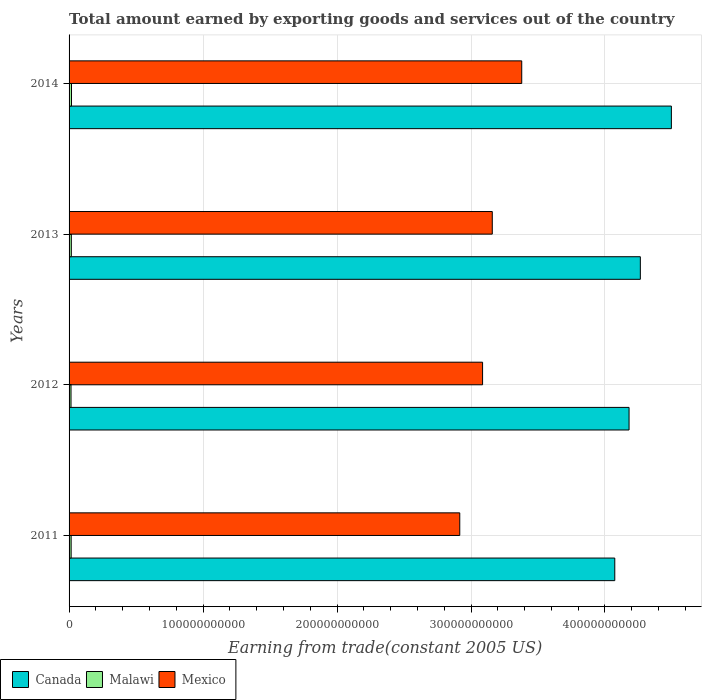Are the number of bars per tick equal to the number of legend labels?
Your response must be concise. Yes. What is the total amount earned by exporting goods and services in Canada in 2014?
Your response must be concise. 4.50e+11. Across all years, what is the maximum total amount earned by exporting goods and services in Malawi?
Your response must be concise. 1.81e+09. Across all years, what is the minimum total amount earned by exporting goods and services in Malawi?
Your answer should be very brief. 1.46e+09. In which year was the total amount earned by exporting goods and services in Canada minimum?
Offer a terse response. 2011. What is the total total amount earned by exporting goods and services in Mexico in the graph?
Offer a terse response. 1.25e+12. What is the difference between the total amount earned by exporting goods and services in Mexico in 2012 and that in 2013?
Keep it short and to the point. -7.25e+09. What is the difference between the total amount earned by exporting goods and services in Mexico in 2011 and the total amount earned by exporting goods and services in Malawi in 2012?
Keep it short and to the point. 2.90e+11. What is the average total amount earned by exporting goods and services in Mexico per year?
Give a very brief answer. 3.13e+11. In the year 2011, what is the difference between the total amount earned by exporting goods and services in Canada and total amount earned by exporting goods and services in Mexico?
Your answer should be very brief. 1.16e+11. In how many years, is the total amount earned by exporting goods and services in Malawi greater than 40000000000 US$?
Your response must be concise. 0. What is the ratio of the total amount earned by exporting goods and services in Canada in 2012 to that in 2014?
Offer a very short reply. 0.93. Is the total amount earned by exporting goods and services in Canada in 2011 less than that in 2012?
Provide a short and direct response. Yes. What is the difference between the highest and the second highest total amount earned by exporting goods and services in Malawi?
Offer a terse response. 1.25e+08. What is the difference between the highest and the lowest total amount earned by exporting goods and services in Malawi?
Ensure brevity in your answer.  3.57e+08. Is the sum of the total amount earned by exporting goods and services in Malawi in 2012 and 2013 greater than the maximum total amount earned by exporting goods and services in Canada across all years?
Offer a very short reply. No. What does the 2nd bar from the top in 2011 represents?
Give a very brief answer. Malawi. How many bars are there?
Offer a very short reply. 12. What is the difference between two consecutive major ticks on the X-axis?
Offer a terse response. 1.00e+11. Are the values on the major ticks of X-axis written in scientific E-notation?
Your answer should be very brief. No. Does the graph contain any zero values?
Your response must be concise. No. How many legend labels are there?
Give a very brief answer. 3. What is the title of the graph?
Give a very brief answer. Total amount earned by exporting goods and services out of the country. Does "Hong Kong" appear as one of the legend labels in the graph?
Keep it short and to the point. No. What is the label or title of the X-axis?
Offer a very short reply. Earning from trade(constant 2005 US). What is the Earning from trade(constant 2005 US) in Canada in 2011?
Provide a succinct answer. 4.07e+11. What is the Earning from trade(constant 2005 US) in Malawi in 2011?
Provide a succinct answer. 1.54e+09. What is the Earning from trade(constant 2005 US) in Mexico in 2011?
Your response must be concise. 2.92e+11. What is the Earning from trade(constant 2005 US) in Canada in 2012?
Provide a succinct answer. 4.18e+11. What is the Earning from trade(constant 2005 US) of Malawi in 2012?
Offer a terse response. 1.46e+09. What is the Earning from trade(constant 2005 US) in Mexico in 2012?
Provide a succinct answer. 3.09e+11. What is the Earning from trade(constant 2005 US) of Canada in 2013?
Your response must be concise. 4.26e+11. What is the Earning from trade(constant 2005 US) of Malawi in 2013?
Keep it short and to the point. 1.69e+09. What is the Earning from trade(constant 2005 US) in Mexico in 2013?
Provide a short and direct response. 3.16e+11. What is the Earning from trade(constant 2005 US) in Canada in 2014?
Your answer should be compact. 4.50e+11. What is the Earning from trade(constant 2005 US) of Malawi in 2014?
Ensure brevity in your answer.  1.81e+09. What is the Earning from trade(constant 2005 US) in Mexico in 2014?
Ensure brevity in your answer.  3.38e+11. Across all years, what is the maximum Earning from trade(constant 2005 US) in Canada?
Your answer should be very brief. 4.50e+11. Across all years, what is the maximum Earning from trade(constant 2005 US) in Malawi?
Your answer should be very brief. 1.81e+09. Across all years, what is the maximum Earning from trade(constant 2005 US) of Mexico?
Provide a succinct answer. 3.38e+11. Across all years, what is the minimum Earning from trade(constant 2005 US) of Canada?
Give a very brief answer. 4.07e+11. Across all years, what is the minimum Earning from trade(constant 2005 US) in Malawi?
Keep it short and to the point. 1.46e+09. Across all years, what is the minimum Earning from trade(constant 2005 US) of Mexico?
Provide a short and direct response. 2.92e+11. What is the total Earning from trade(constant 2005 US) of Canada in the graph?
Provide a short and direct response. 1.70e+12. What is the total Earning from trade(constant 2005 US) in Malawi in the graph?
Your answer should be compact. 6.50e+09. What is the total Earning from trade(constant 2005 US) of Mexico in the graph?
Ensure brevity in your answer.  1.25e+12. What is the difference between the Earning from trade(constant 2005 US) in Canada in 2011 and that in 2012?
Keep it short and to the point. -1.07e+1. What is the difference between the Earning from trade(constant 2005 US) in Malawi in 2011 and that in 2012?
Give a very brief answer. 8.46e+07. What is the difference between the Earning from trade(constant 2005 US) of Mexico in 2011 and that in 2012?
Your response must be concise. -1.70e+1. What is the difference between the Earning from trade(constant 2005 US) of Canada in 2011 and that in 2013?
Your answer should be compact. -1.91e+1. What is the difference between the Earning from trade(constant 2005 US) in Malawi in 2011 and that in 2013?
Your answer should be compact. -1.48e+08. What is the difference between the Earning from trade(constant 2005 US) in Mexico in 2011 and that in 2013?
Offer a terse response. -2.43e+1. What is the difference between the Earning from trade(constant 2005 US) of Canada in 2011 and that in 2014?
Your answer should be compact. -4.22e+1. What is the difference between the Earning from trade(constant 2005 US) in Malawi in 2011 and that in 2014?
Provide a short and direct response. -2.72e+08. What is the difference between the Earning from trade(constant 2005 US) of Mexico in 2011 and that in 2014?
Offer a very short reply. -4.63e+1. What is the difference between the Earning from trade(constant 2005 US) of Canada in 2012 and that in 2013?
Provide a short and direct response. -8.42e+09. What is the difference between the Earning from trade(constant 2005 US) of Malawi in 2012 and that in 2013?
Offer a terse response. -2.32e+08. What is the difference between the Earning from trade(constant 2005 US) of Mexico in 2012 and that in 2013?
Make the answer very short. -7.25e+09. What is the difference between the Earning from trade(constant 2005 US) of Canada in 2012 and that in 2014?
Your answer should be very brief. -3.16e+1. What is the difference between the Earning from trade(constant 2005 US) in Malawi in 2012 and that in 2014?
Keep it short and to the point. -3.57e+08. What is the difference between the Earning from trade(constant 2005 US) of Mexico in 2012 and that in 2014?
Offer a terse response. -2.92e+1. What is the difference between the Earning from trade(constant 2005 US) in Canada in 2013 and that in 2014?
Offer a terse response. -2.32e+1. What is the difference between the Earning from trade(constant 2005 US) of Malawi in 2013 and that in 2014?
Your answer should be compact. -1.25e+08. What is the difference between the Earning from trade(constant 2005 US) of Mexico in 2013 and that in 2014?
Your answer should be compact. -2.20e+1. What is the difference between the Earning from trade(constant 2005 US) in Canada in 2011 and the Earning from trade(constant 2005 US) in Malawi in 2012?
Give a very brief answer. 4.06e+11. What is the difference between the Earning from trade(constant 2005 US) in Canada in 2011 and the Earning from trade(constant 2005 US) in Mexico in 2012?
Provide a succinct answer. 9.87e+1. What is the difference between the Earning from trade(constant 2005 US) of Malawi in 2011 and the Earning from trade(constant 2005 US) of Mexico in 2012?
Give a very brief answer. -3.07e+11. What is the difference between the Earning from trade(constant 2005 US) of Canada in 2011 and the Earning from trade(constant 2005 US) of Malawi in 2013?
Ensure brevity in your answer.  4.06e+11. What is the difference between the Earning from trade(constant 2005 US) in Canada in 2011 and the Earning from trade(constant 2005 US) in Mexico in 2013?
Offer a terse response. 9.14e+1. What is the difference between the Earning from trade(constant 2005 US) in Malawi in 2011 and the Earning from trade(constant 2005 US) in Mexico in 2013?
Make the answer very short. -3.14e+11. What is the difference between the Earning from trade(constant 2005 US) in Canada in 2011 and the Earning from trade(constant 2005 US) in Malawi in 2014?
Offer a terse response. 4.05e+11. What is the difference between the Earning from trade(constant 2005 US) of Canada in 2011 and the Earning from trade(constant 2005 US) of Mexico in 2014?
Keep it short and to the point. 6.94e+1. What is the difference between the Earning from trade(constant 2005 US) of Malawi in 2011 and the Earning from trade(constant 2005 US) of Mexico in 2014?
Give a very brief answer. -3.36e+11. What is the difference between the Earning from trade(constant 2005 US) in Canada in 2012 and the Earning from trade(constant 2005 US) in Malawi in 2013?
Keep it short and to the point. 4.16e+11. What is the difference between the Earning from trade(constant 2005 US) of Canada in 2012 and the Earning from trade(constant 2005 US) of Mexico in 2013?
Offer a terse response. 1.02e+11. What is the difference between the Earning from trade(constant 2005 US) in Malawi in 2012 and the Earning from trade(constant 2005 US) in Mexico in 2013?
Give a very brief answer. -3.14e+11. What is the difference between the Earning from trade(constant 2005 US) of Canada in 2012 and the Earning from trade(constant 2005 US) of Malawi in 2014?
Your answer should be very brief. 4.16e+11. What is the difference between the Earning from trade(constant 2005 US) in Canada in 2012 and the Earning from trade(constant 2005 US) in Mexico in 2014?
Ensure brevity in your answer.  8.01e+1. What is the difference between the Earning from trade(constant 2005 US) of Malawi in 2012 and the Earning from trade(constant 2005 US) of Mexico in 2014?
Your answer should be compact. -3.36e+11. What is the difference between the Earning from trade(constant 2005 US) in Canada in 2013 and the Earning from trade(constant 2005 US) in Malawi in 2014?
Ensure brevity in your answer.  4.25e+11. What is the difference between the Earning from trade(constant 2005 US) in Canada in 2013 and the Earning from trade(constant 2005 US) in Mexico in 2014?
Your answer should be compact. 8.85e+1. What is the difference between the Earning from trade(constant 2005 US) in Malawi in 2013 and the Earning from trade(constant 2005 US) in Mexico in 2014?
Give a very brief answer. -3.36e+11. What is the average Earning from trade(constant 2005 US) of Canada per year?
Give a very brief answer. 4.25e+11. What is the average Earning from trade(constant 2005 US) of Malawi per year?
Offer a terse response. 1.62e+09. What is the average Earning from trade(constant 2005 US) in Mexico per year?
Keep it short and to the point. 3.13e+11. In the year 2011, what is the difference between the Earning from trade(constant 2005 US) of Canada and Earning from trade(constant 2005 US) of Malawi?
Offer a very short reply. 4.06e+11. In the year 2011, what is the difference between the Earning from trade(constant 2005 US) of Canada and Earning from trade(constant 2005 US) of Mexico?
Make the answer very short. 1.16e+11. In the year 2011, what is the difference between the Earning from trade(constant 2005 US) in Malawi and Earning from trade(constant 2005 US) in Mexico?
Provide a short and direct response. -2.90e+11. In the year 2012, what is the difference between the Earning from trade(constant 2005 US) in Canada and Earning from trade(constant 2005 US) in Malawi?
Give a very brief answer. 4.17e+11. In the year 2012, what is the difference between the Earning from trade(constant 2005 US) of Canada and Earning from trade(constant 2005 US) of Mexico?
Your answer should be compact. 1.09e+11. In the year 2012, what is the difference between the Earning from trade(constant 2005 US) in Malawi and Earning from trade(constant 2005 US) in Mexico?
Keep it short and to the point. -3.07e+11. In the year 2013, what is the difference between the Earning from trade(constant 2005 US) in Canada and Earning from trade(constant 2005 US) in Malawi?
Provide a succinct answer. 4.25e+11. In the year 2013, what is the difference between the Earning from trade(constant 2005 US) of Canada and Earning from trade(constant 2005 US) of Mexico?
Offer a terse response. 1.11e+11. In the year 2013, what is the difference between the Earning from trade(constant 2005 US) in Malawi and Earning from trade(constant 2005 US) in Mexico?
Give a very brief answer. -3.14e+11. In the year 2014, what is the difference between the Earning from trade(constant 2005 US) of Canada and Earning from trade(constant 2005 US) of Malawi?
Keep it short and to the point. 4.48e+11. In the year 2014, what is the difference between the Earning from trade(constant 2005 US) of Canada and Earning from trade(constant 2005 US) of Mexico?
Your answer should be very brief. 1.12e+11. In the year 2014, what is the difference between the Earning from trade(constant 2005 US) in Malawi and Earning from trade(constant 2005 US) in Mexico?
Your answer should be compact. -3.36e+11. What is the ratio of the Earning from trade(constant 2005 US) in Canada in 2011 to that in 2012?
Offer a very short reply. 0.97. What is the ratio of the Earning from trade(constant 2005 US) of Malawi in 2011 to that in 2012?
Give a very brief answer. 1.06. What is the ratio of the Earning from trade(constant 2005 US) in Mexico in 2011 to that in 2012?
Offer a very short reply. 0.94. What is the ratio of the Earning from trade(constant 2005 US) in Canada in 2011 to that in 2013?
Provide a succinct answer. 0.96. What is the ratio of the Earning from trade(constant 2005 US) in Malawi in 2011 to that in 2013?
Ensure brevity in your answer.  0.91. What is the ratio of the Earning from trade(constant 2005 US) of Mexico in 2011 to that in 2013?
Your answer should be very brief. 0.92. What is the ratio of the Earning from trade(constant 2005 US) of Canada in 2011 to that in 2014?
Provide a short and direct response. 0.91. What is the ratio of the Earning from trade(constant 2005 US) in Malawi in 2011 to that in 2014?
Provide a short and direct response. 0.85. What is the ratio of the Earning from trade(constant 2005 US) of Mexico in 2011 to that in 2014?
Provide a succinct answer. 0.86. What is the ratio of the Earning from trade(constant 2005 US) of Canada in 2012 to that in 2013?
Make the answer very short. 0.98. What is the ratio of the Earning from trade(constant 2005 US) in Malawi in 2012 to that in 2013?
Ensure brevity in your answer.  0.86. What is the ratio of the Earning from trade(constant 2005 US) of Mexico in 2012 to that in 2013?
Make the answer very short. 0.98. What is the ratio of the Earning from trade(constant 2005 US) of Canada in 2012 to that in 2014?
Provide a short and direct response. 0.93. What is the ratio of the Earning from trade(constant 2005 US) of Malawi in 2012 to that in 2014?
Your response must be concise. 0.8. What is the ratio of the Earning from trade(constant 2005 US) of Mexico in 2012 to that in 2014?
Your answer should be compact. 0.91. What is the ratio of the Earning from trade(constant 2005 US) in Canada in 2013 to that in 2014?
Your response must be concise. 0.95. What is the ratio of the Earning from trade(constant 2005 US) in Malawi in 2013 to that in 2014?
Make the answer very short. 0.93. What is the ratio of the Earning from trade(constant 2005 US) of Mexico in 2013 to that in 2014?
Your answer should be very brief. 0.93. What is the difference between the highest and the second highest Earning from trade(constant 2005 US) of Canada?
Offer a very short reply. 2.32e+1. What is the difference between the highest and the second highest Earning from trade(constant 2005 US) of Malawi?
Your answer should be very brief. 1.25e+08. What is the difference between the highest and the second highest Earning from trade(constant 2005 US) in Mexico?
Give a very brief answer. 2.20e+1. What is the difference between the highest and the lowest Earning from trade(constant 2005 US) in Canada?
Ensure brevity in your answer.  4.22e+1. What is the difference between the highest and the lowest Earning from trade(constant 2005 US) of Malawi?
Your response must be concise. 3.57e+08. What is the difference between the highest and the lowest Earning from trade(constant 2005 US) in Mexico?
Provide a short and direct response. 4.63e+1. 